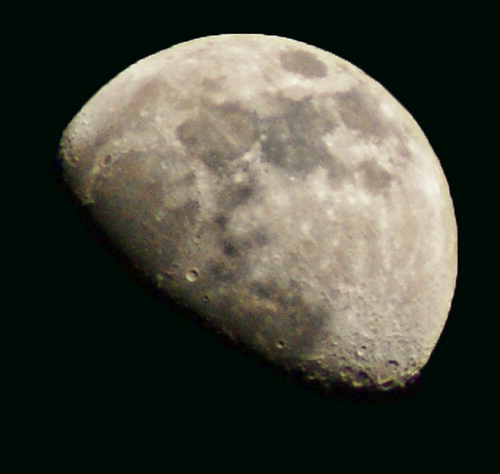<image>
Is there a moon in the space? Yes. The moon is contained within or inside the space, showing a containment relationship. 